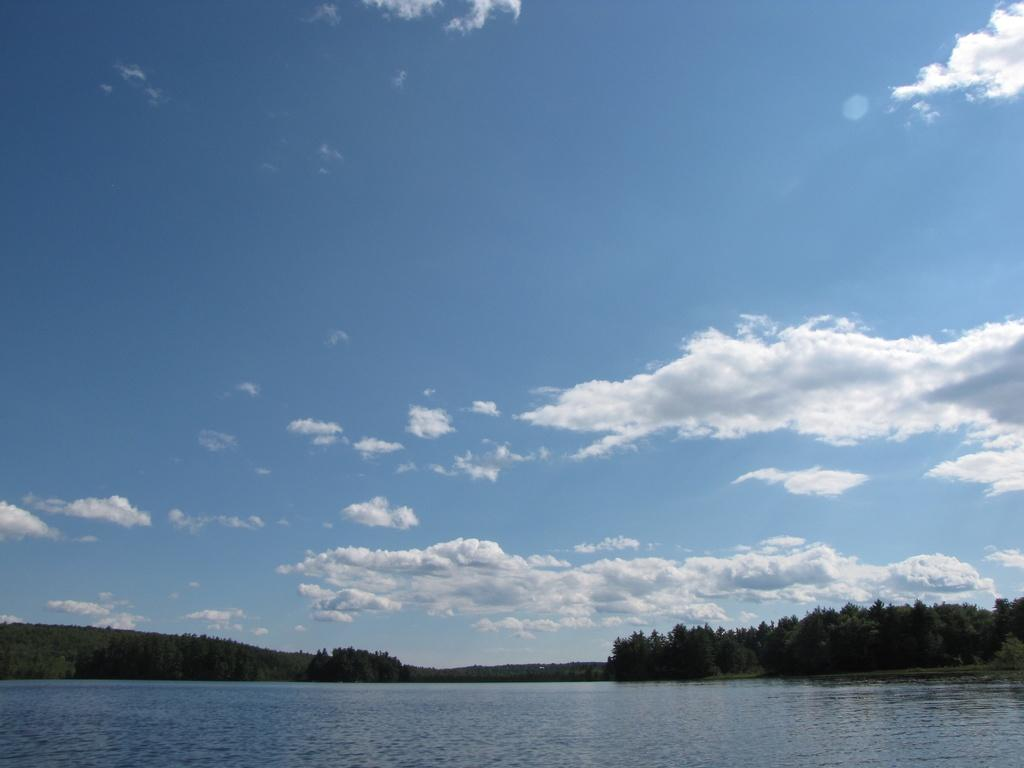What is one of the main elements in the picture? There is water in the picture. What type of vegetation can be seen in the picture? There are trees in the picture. How would you describe the sky in the picture? The sky is blue and cloudy in the picture. What type of plant is leading the group of tourists in the picture? There are no plants or tourists present in the image, so this question cannot be answered. 